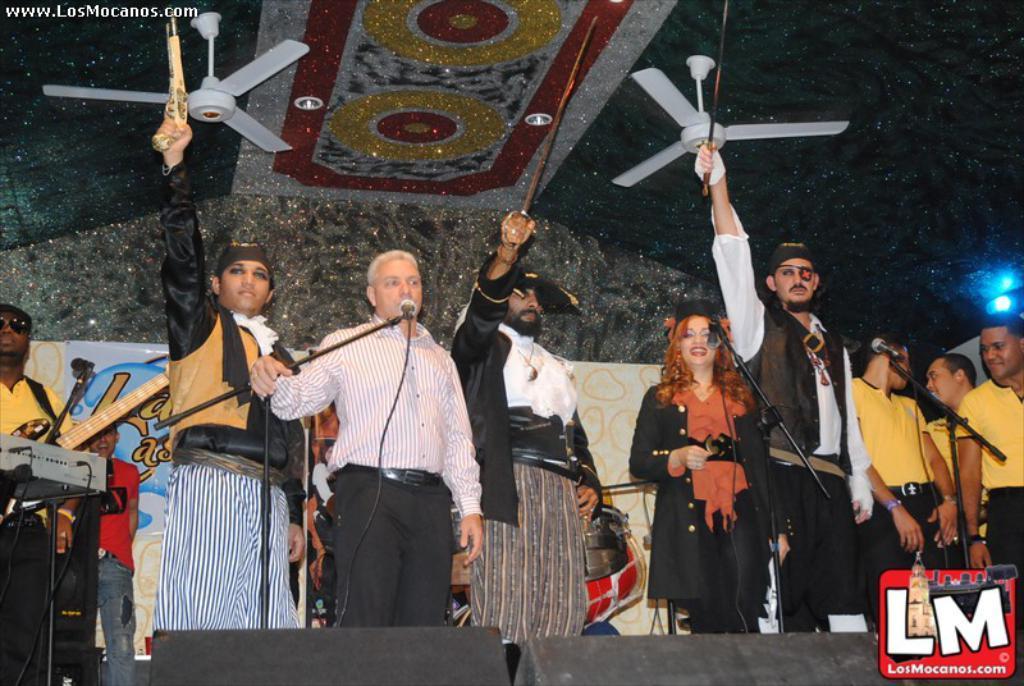Can you describe this image briefly? In this picture I can see there are a few people standing on the dais and few people are wearing pirate costumes and I can see there is a man standing at left and speaking into the microphone, there are a few people standing on the right side, they are wearing yellow shirts. There is a person at left, he is playing the guitar. There is a logo at the right bottom of the image, there is a light onto right side. 